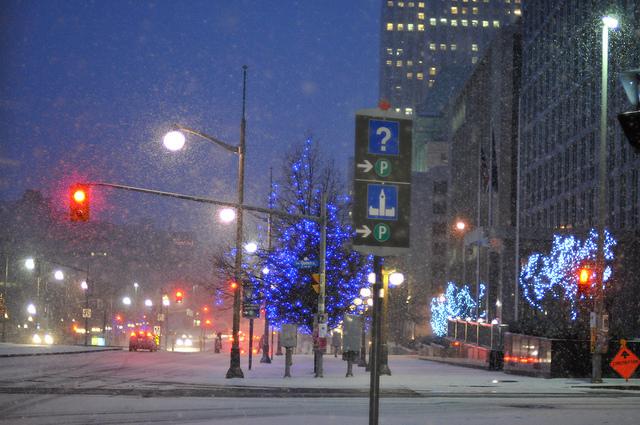What color are the lights on the trees?
Keep it brief. Blue. Which way is the arrow pointing?
Concise answer only. Right. What color is the road?
Concise answer only. White. What holiday is the scene decorated for?
Short answer required. Christmas. Do the lights have a pattern?
Write a very short answer. Yes. 